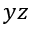<formula> <loc_0><loc_0><loc_500><loc_500>y z</formula> 